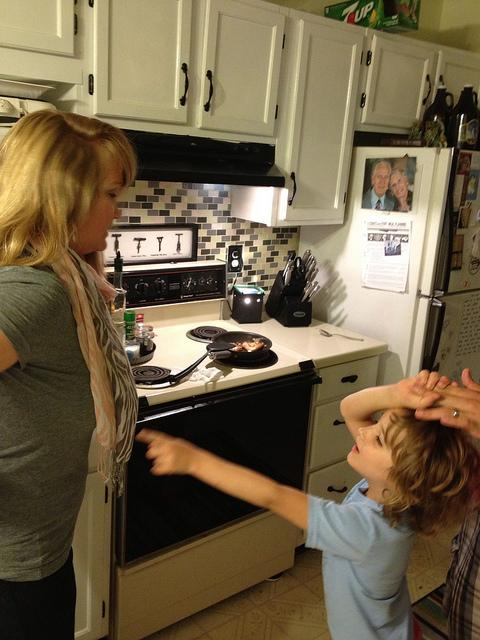What is the original flavor of the beverage? water 